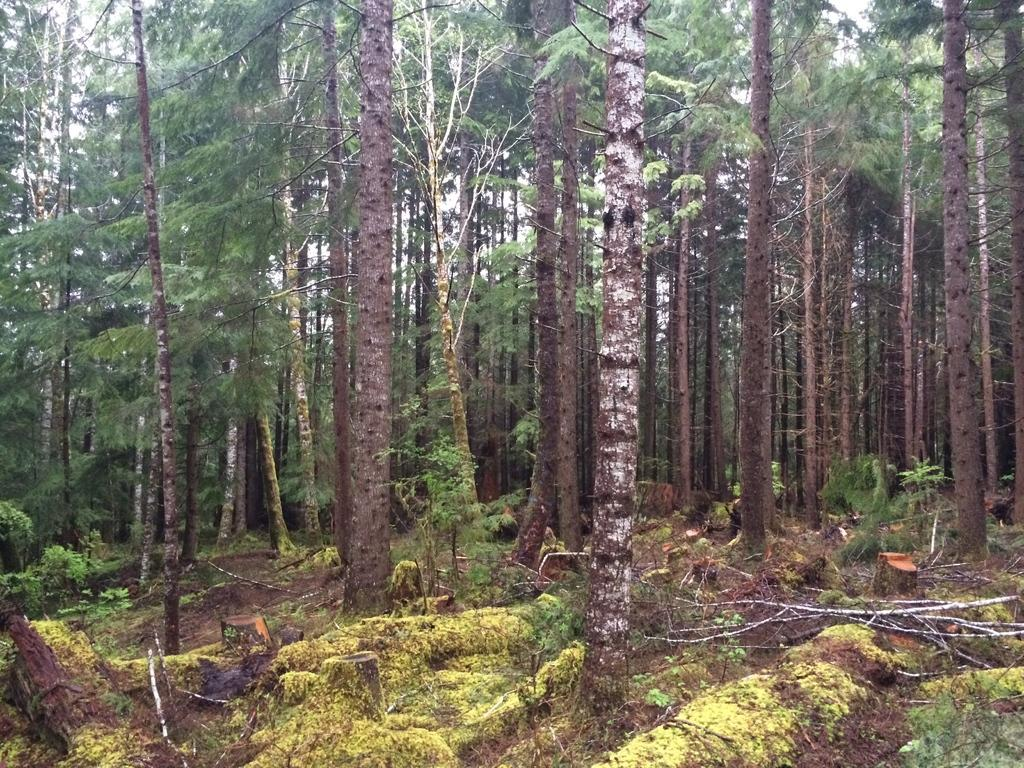What type of vegetation can be seen in the image? There are trees in the image. What other objects can be found on the ground in the image? There are dry sticks in the image. What type of grain is growing on the trees in the image? There is no grain growing on the trees in the image; the trees are not mentioned as having any fruit or grain. 